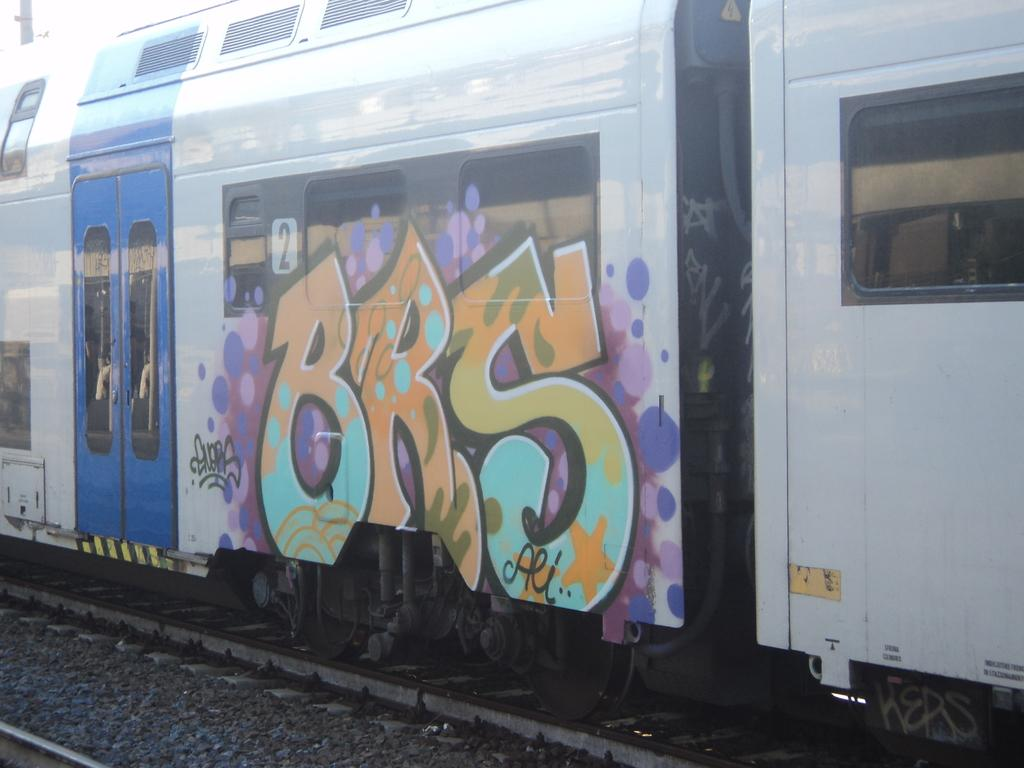What is the main subject of the image? There is a train in the image. Where is the train located? The train is on a train track. What can be seen in the image besides the train? The train track is visible in the image, as well as stones near the train track. Is there any decoration or artwork on the train? Yes, there is a painting on the train coach. What type of joke can be seen on the train's control panel in the image? There is no joke or control panel present in the image; it features a train on a train track with a painting on the train coach. 